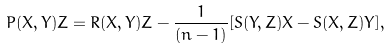<formula> <loc_0><loc_0><loc_500><loc_500>P ( X , Y ) Z = R ( X , Y ) Z - \frac { 1 } { ( n - 1 ) } [ S ( Y , Z ) X - S ( X , Z ) Y ] ,</formula> 